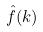Convert formula to latex. <formula><loc_0><loc_0><loc_500><loc_500>\hat { f } ( k )</formula> 